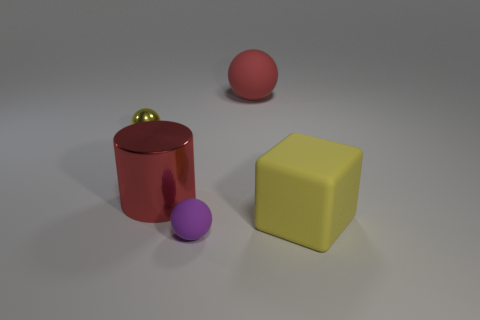Subtract all large balls. How many balls are left? 2 Add 4 purple balls. How many objects exist? 9 Subtract all small rubber objects. Subtract all yellow blocks. How many objects are left? 3 Add 2 red spheres. How many red spheres are left? 3 Add 5 purple spheres. How many purple spheres exist? 6 Subtract 0 gray cylinders. How many objects are left? 5 Subtract all cylinders. How many objects are left? 4 